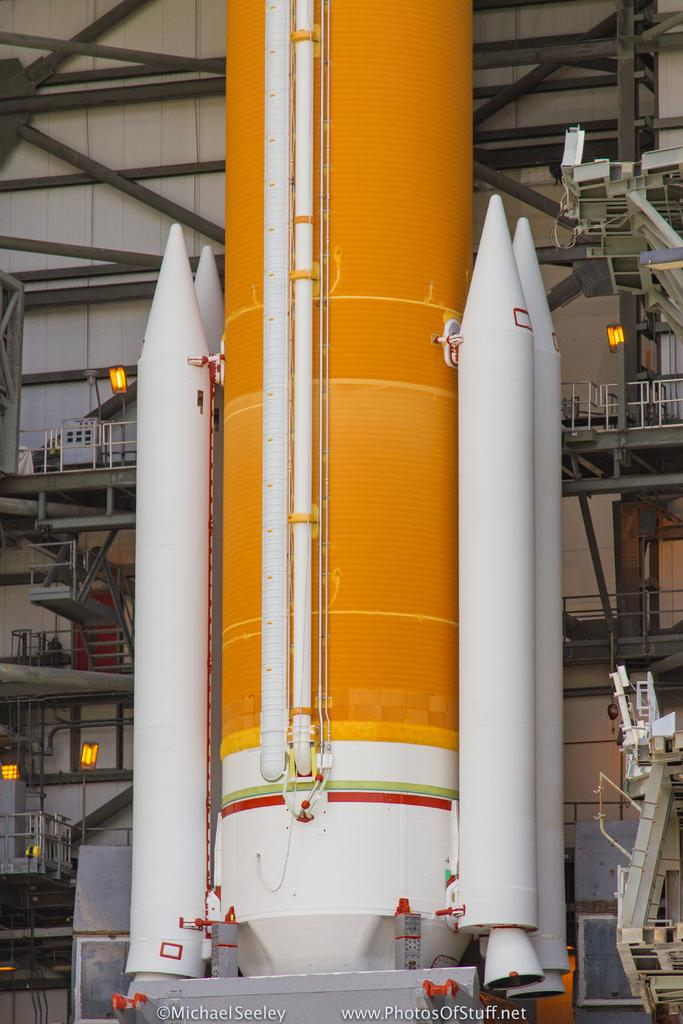What is the main subject of the image? There is a rocket in the image. What can be seen in the background of the image? In the background of the image, there is a ladder, railings, and iron rods. Are there any light sources visible in the image? Yes, there are lights in the image. Is there any text present in the image? Yes, there is text at the bottom of the image. What is the price of the apple in the image? There is no apple present in the image, so it is not possible to determine its price. How much cheese can be seen in the image? There is no cheese present in the image. 